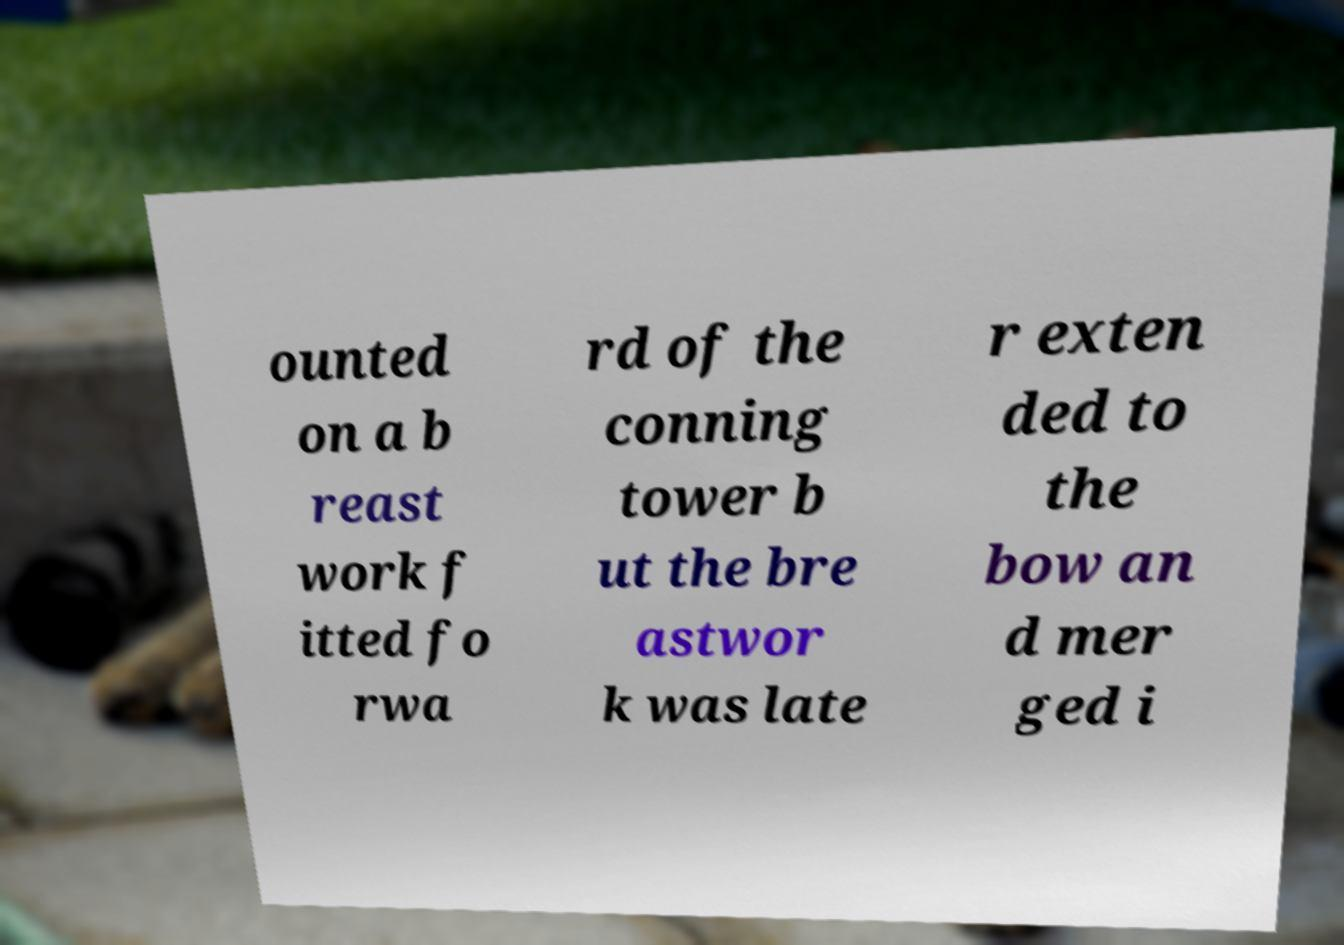For documentation purposes, I need the text within this image transcribed. Could you provide that? ounted on a b reast work f itted fo rwa rd of the conning tower b ut the bre astwor k was late r exten ded to the bow an d mer ged i 